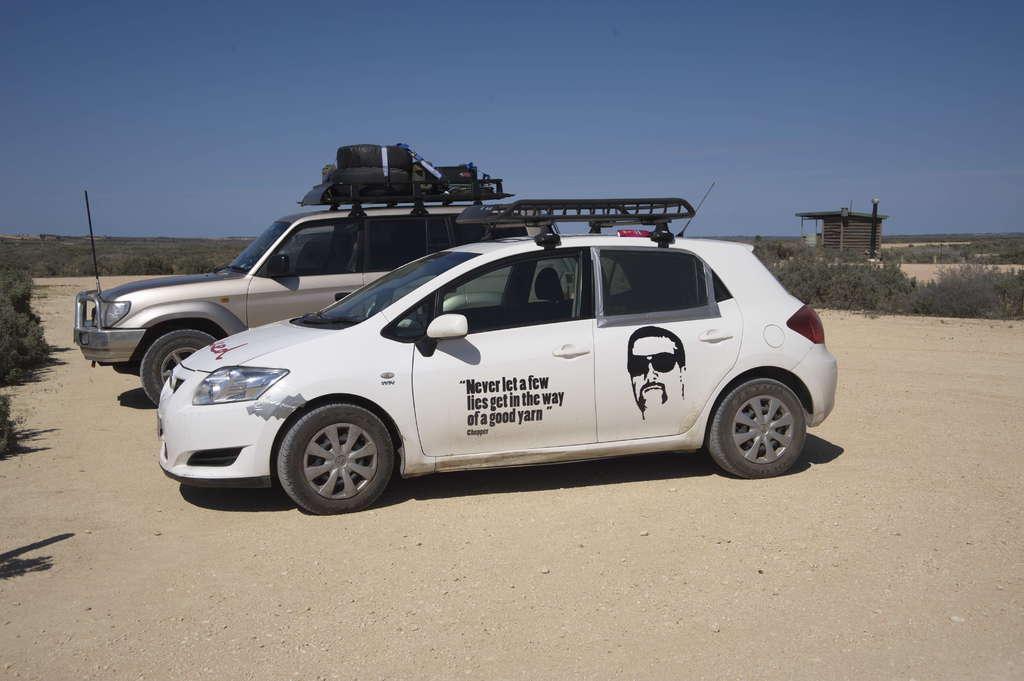Could you give a brief overview of what you see in this image? In this image we can see the depiction of a person and also the text on the car. We can also see the other car parked on the sand road. We can see the plants, roof for shelter and also the sky. 